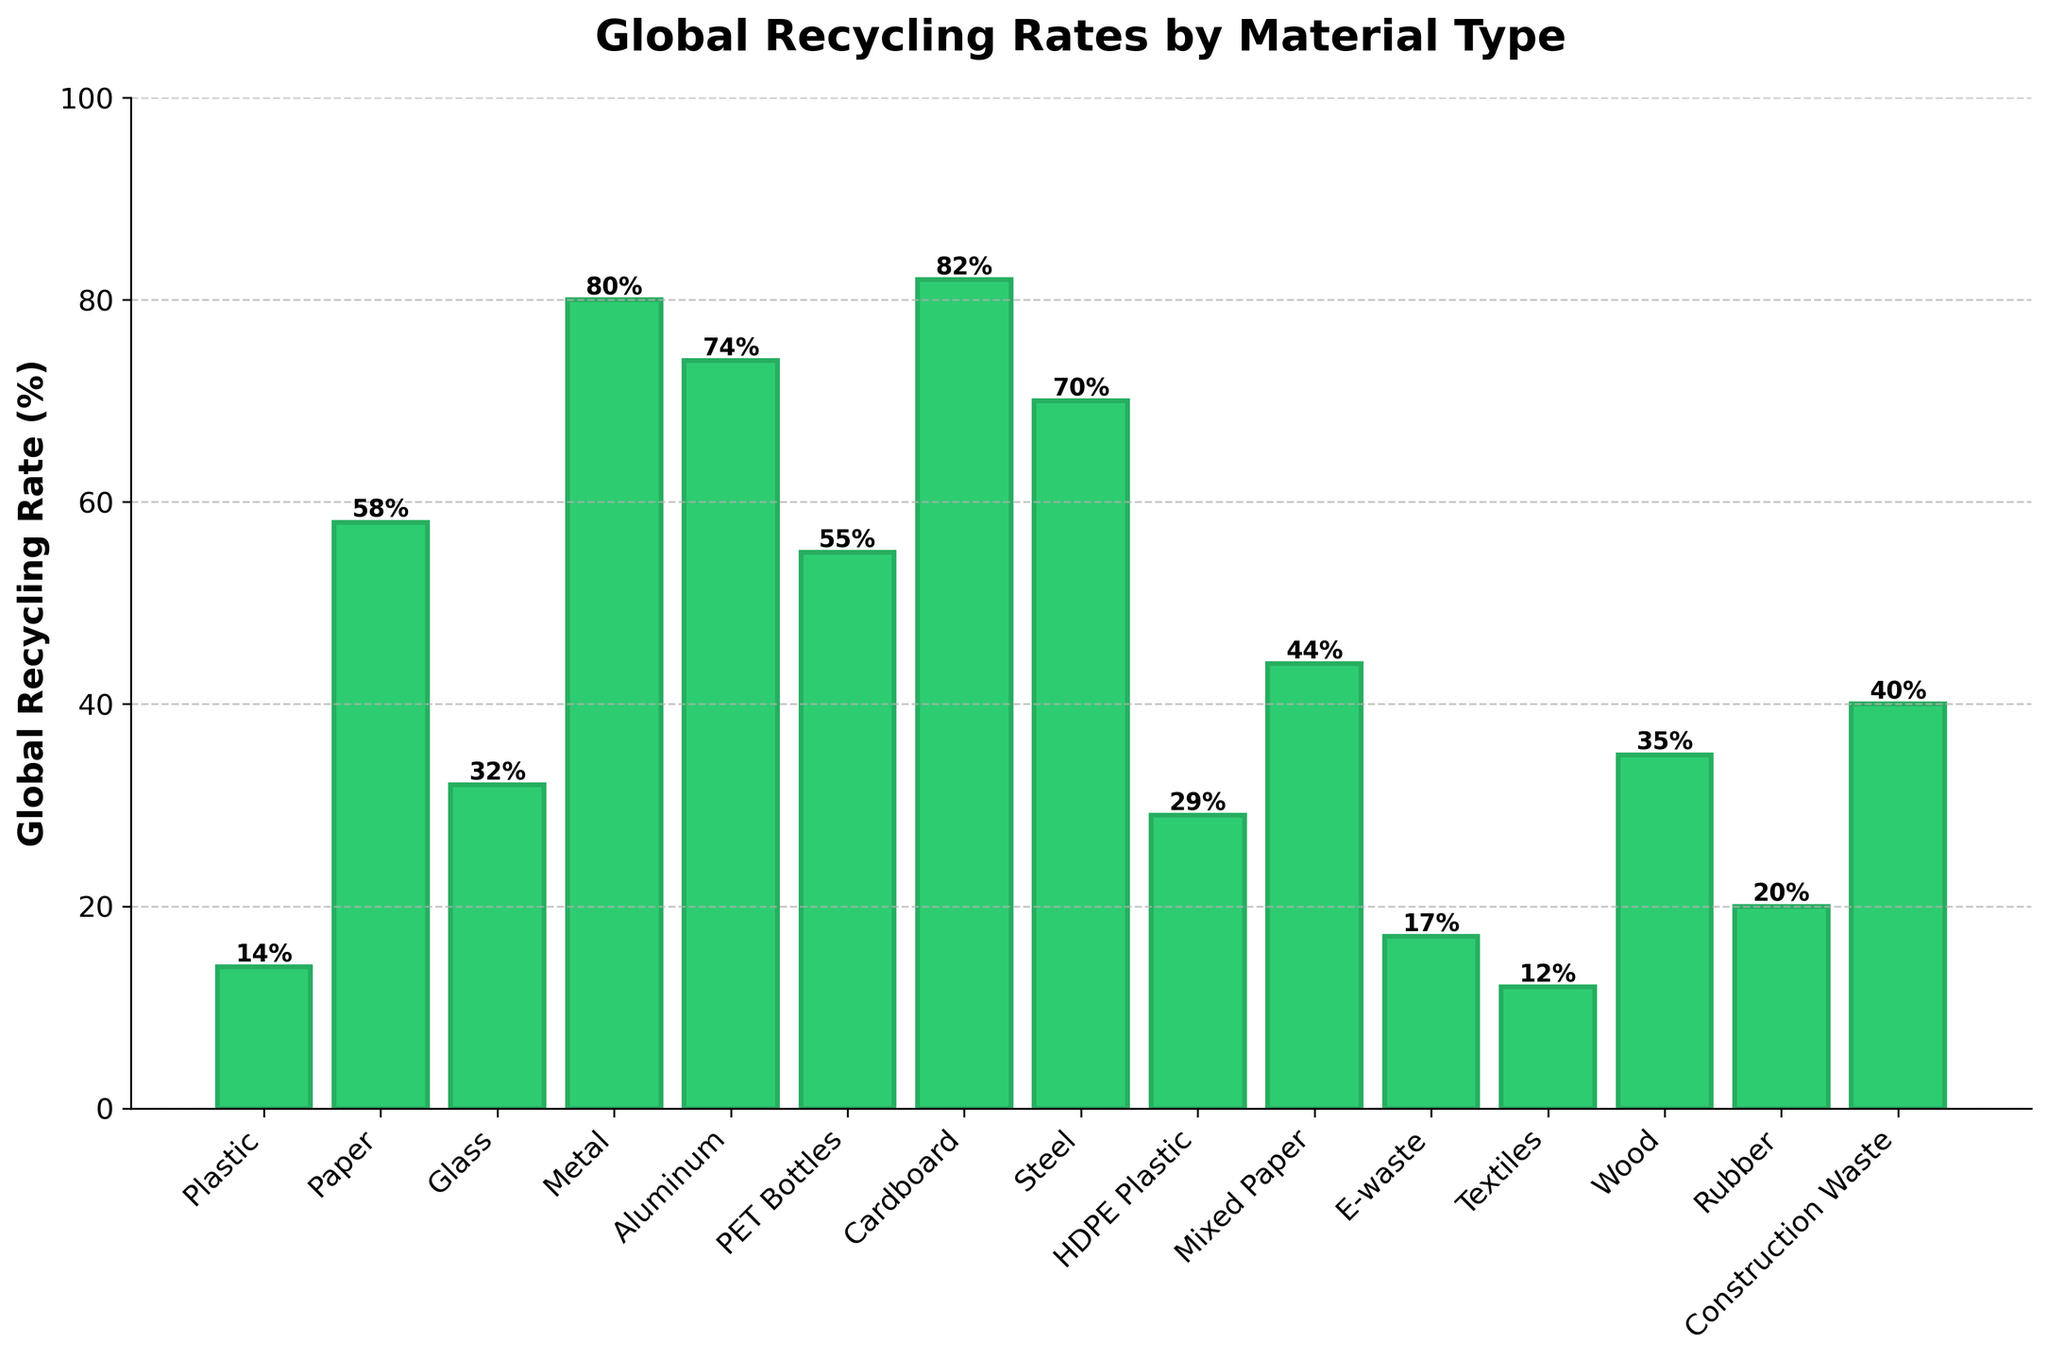What material has the highest global recycling rate? Look at the bar with the highest height. The "Cardboard" bar is the tallest, indicating it has the highest recycling rate.
Answer: Cardboard Which material has the lowest global recycling rate? Identify the shortest bar in the chart. The "Textiles" bar is the shortest, which shows it has the lowest recycling rate.
Answer: Textiles How much higher is the recycling rate of Metal compared to Plastic? Subtract the recycling rate of Plastic (14%) from the rate of Metal (80%). The difference is 80% - 14%.
Answer: 66% Which materials have a recycling rate higher than 70%? Check all bars that exceed the 70% mark on the y-axis. "Cardboard" (82%), "Metal" (80%), and "Aluminum" (74%) surpass this value.
Answer: Cardboard, Metal, Aluminum What is the average global recycling rate of Paper, Glass, and Rubber? Sum the recycling rates of Paper (58%), Glass (32%), and Rubber (20%), then divide by 3. The calculation is (58 + 32 + 20) / 3.
Answer: 36.67% Is the recycling rate of HDPE Plastic more than double that of E-waste? Double the rate of E-waste (17%) to get 34%. Compare this with HDPE Plastic's rate (29%). Since 29% < 34%, it's not more than double.
Answer: No Compare the recycling rates of Aluminum and Steel. Which is higher, and by how much? Subtract the recycling rate of Steel (70%) from Aluminum (74%). Since 74% > 70%, Aluminum is higher by 4%.
Answer: Aluminum, 4% What is the median recycling rate of all materials? Order the recycling rates and find the middle value(s). The sorted rates are: 12, 14, 17, 20, 29, 32, 35, 40, 44, 55, 58, 70, 74, 80, 82. The median is the 8th value in the list, which is 40%.
Answer: 40% Which materials have similar recycling rates close to 14% and 17% respectively? Look for bars near these heights on the y-axis. "Plastic" is near 14%, and "E-waste" is close to 17%.
Answer: Plastic, E-waste Is the average recycling rate of Metal and Aluminum higher than that of Paper and Glass combined? Calculate the averages for Metal and Aluminum, and Paper and Glass.
(1) Average of Metal (80%) and Aluminum (74%) = (80 + 74) / 2 = 77%.
(2) Average of Paper (58%) and Glass (32%) = (58 + 32) / 2 = 45%.
77% > 45%, so the average rate for Metal and Aluminum is higher.
Answer: Yes 